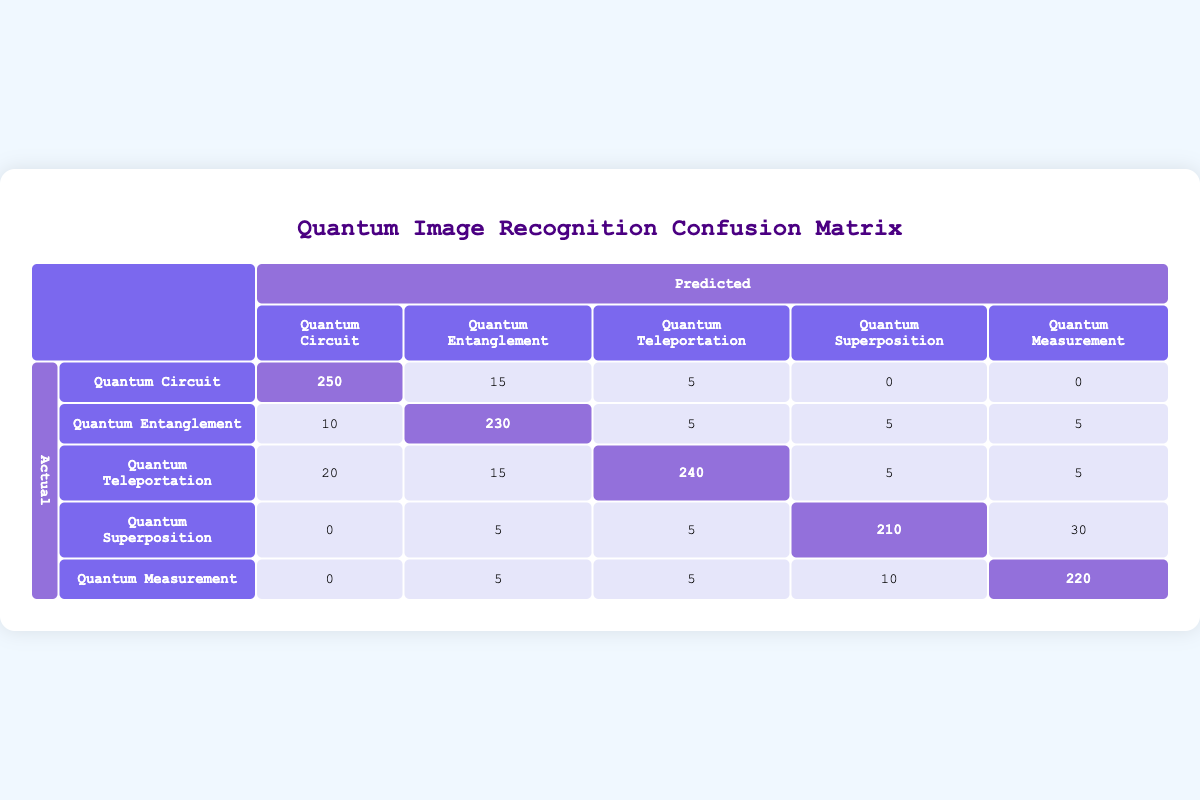What is the total number of images classified as Quantum Circuit? The table indicates that the actual number of images classified as Quantum Circuit is 250 correct and 20 incorrect. Therefore, the total is 250 + 20 = 270.
Answer: 270 Which class has the highest number of correctly identified images? Reviewing the correct counts—Quantum Circuit has 250, Quantum Entanglement has 230, Quantum Teleportation has 240, Quantum Superposition has 210, and Quantum Measurement has 220. The highest count is for Quantum Circuit with 250 correct.
Answer: Quantum Circuit What percentage of Quantum Measurement images were classified incorrectly? The table shows that there are 220 correctly identified images and 35 incorrectly identified images for Quantum Measurement. To find the percentage of incorrectly classified images, we can calculate (35 / (220 + 35)) * 100 = (35 / 255) * 100 ≈ 13.73%.
Answer: Approximately 13.73% How many images were misclassified as Quantum Entanglement instead of Quantum Circuit? From the table, 15 images predicted as Quantum Entanglement when they were actually Quantum Circuit. Therefore, the number of misclassified images is directly available in the table as 15.
Answer: 15 What is the overall accuracy for Quantum Teleportation recognition? To determine the overall accuracy for Quantum Teleportation, we need to sum the correct and incorrect classifications: correct = 240, incorrect = 25. The total is 240 + 25 = 265, and the accuracy is (240 / 265) * 100 ≈ 90.57%.
Answer: Approximately 90.57% Is it true that more incorrect predictions were made for Quantum Superposition than for Quantum Circuit? From the table, Quantum Superposition has 40 incorrect predictions while Quantum Circuit has 20. Since 40 is greater than 20, the statement is true.
Answer: Yes What is the total number of correct predictions across all classes? Adding the correct predictions: Quantum Circuit (250) + Quantum Entanglement (230) + Quantum Teleportation (240) + Quantum Superposition (210) + Quantum Measurement (220) gives a total of 250 + 230 + 240 + 210 + 220 = 1150 correct predictions.
Answer: 1150 Which class had the lowest number of correct predictions? Examining the correct counts—Quantum Circuit (250), Quantum Entanglement (230), Quantum Teleportation (240), Quantum Superposition (210), Quantum Measurement (220)—the lowest is Quantum Superposition, which has 210 correct.
Answer: Quantum Superposition What is the sum of incorrect predictions for Quantum Circuit and Quantum Measurement? The incorrect predictions for Quantum Circuit is 20 and for Quantum Measurement is 35. Adding these gives 20 + 35 = 55.
Answer: 55 